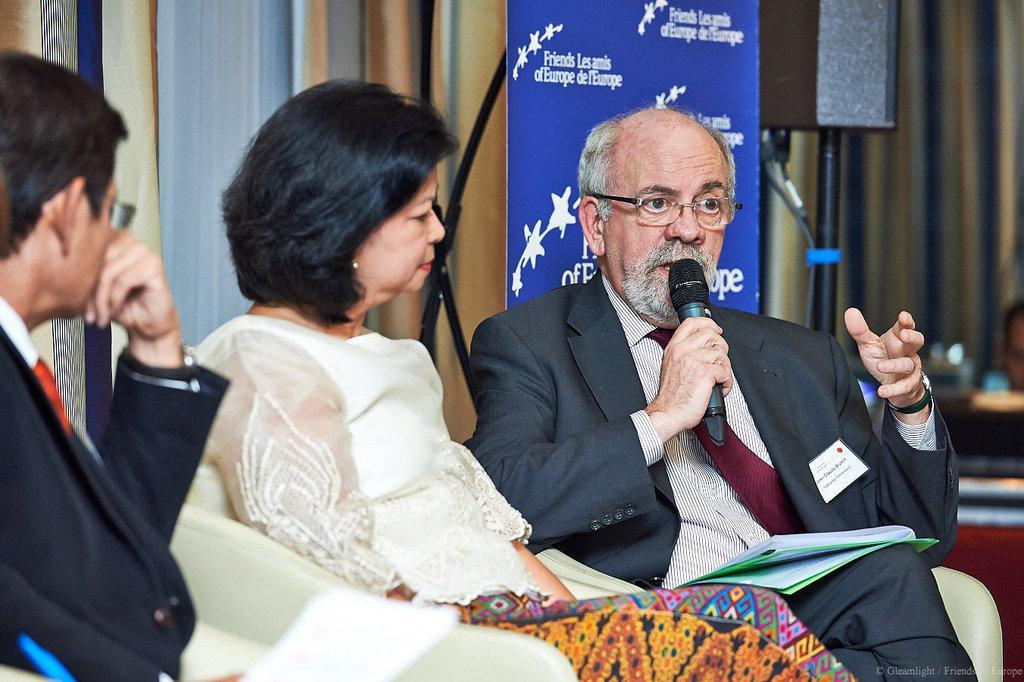Can you describe this image briefly? In this image, there are two men and a woman sitting on the chairs. This man is holding a mike in his hand and speaking. This looks like a banner. I think this is a speaker with the stand. In the background, these look like the curtains hanging. At the bottom of the image, I can see the watermark. 